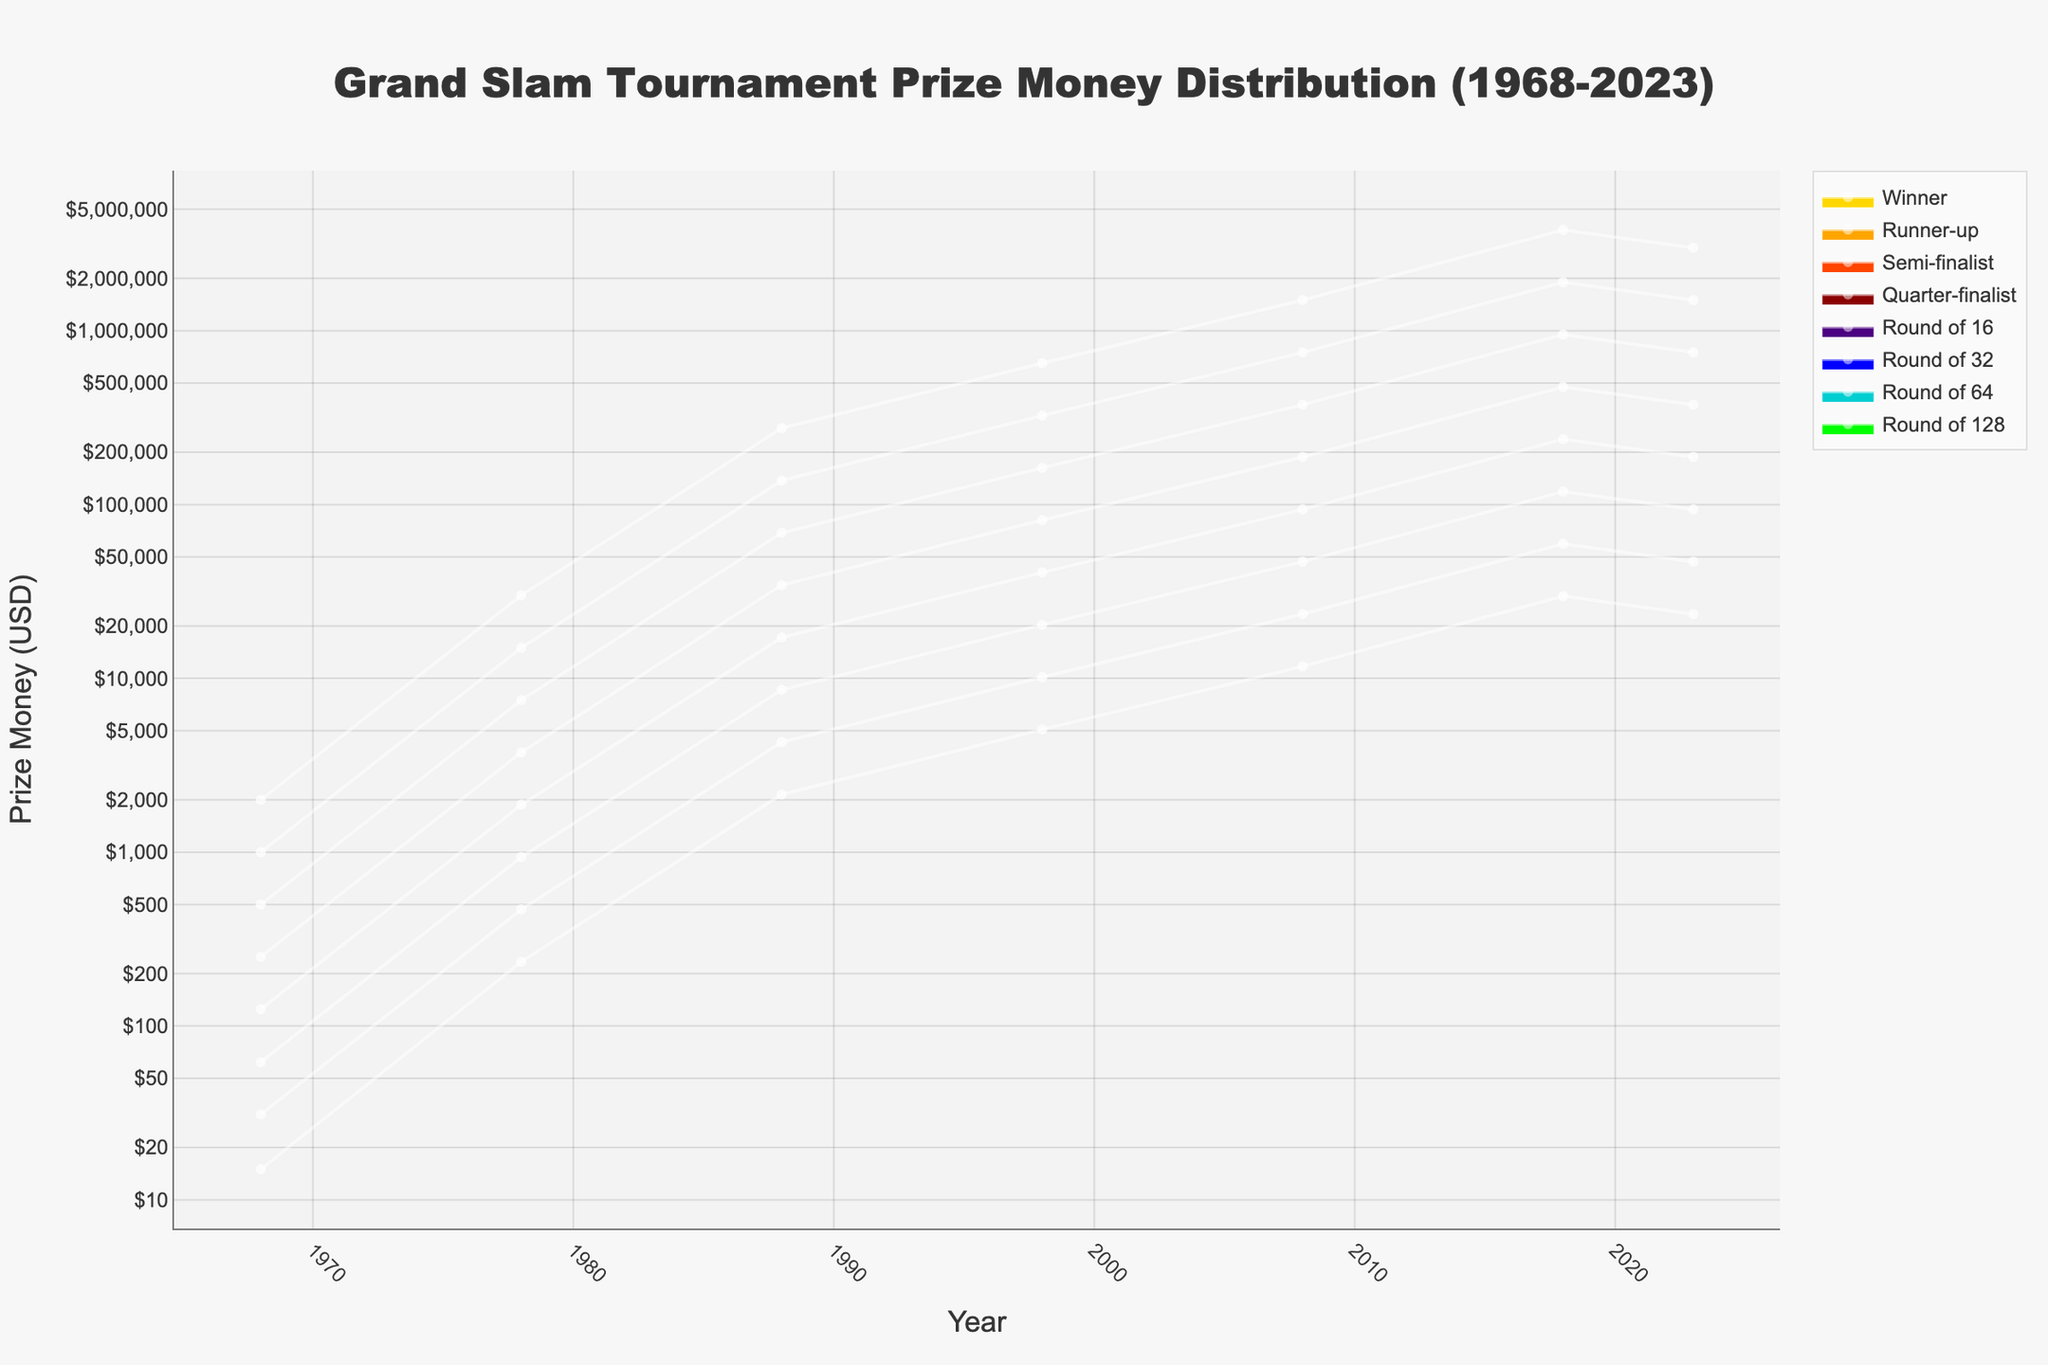What is the title of the figure? The title is usually at the top of the figure, summarized in a few words to denote the content of the chart.
Answer: Grand Slam Tournament Prize Money Distribution (1968-2023) How much prize money did the runner-up receive in 1988? The figure plots the prize money for each round over the years. Locate the year 1988 and then check the corresponding value for the runner-up.
Answer: $137,500 How did the prize money for the winners change from 2008 to 2023? To find this, look at the prize money for winners in 2008 and then in 2023. Calculate the difference between the two values.
Answer: Increased by $1,500,000 Which year shows the steepest increase in prize money for winners? Check the plot for significant jumps in the prize money for winners between consecutive years. The steepest, most noticeable increase will indicate the correct year.
Answer: 1978 Compare the prize money for semi-finalists and quarter-finalists in 2018. Which one is higher, and by how much? Locate the prize money values for semi-finalists and quarter-finalists in 2018. Subtract the quarter-finalist's amount from the semi-finalist's amount to find the difference.
Answer: Semi-finalists; $475,000 What is the general trend of the prize money from 1968 to 2023? Observe the overall direction of the prize money values across all rounds over the years. Identify if it's increasing, decreasing, or fluctuating.
Answer: Increasing In which round and year does the lowest prize money appear on the chart? Look for the smallest prize money value within the entire chart, noting the corresponding round and year.
Answer: Round of 128, 1968 Which round had a prize money of $1,406,250 in any given year? Identify from the figure where this specific value fits within the plotted data points across all rounds and years.
Answer: It does not exactly match any plotted value What is the prize money distribution pattern in 1978 compared to 1988? Contrast the prize money values for all rounds between the years 1978 and 1988, observing patterns or percentage increases.
Answer: Increased significantly across all rounds How does the prize money for winners evolve from 1968 to 2023? Focus on the winners' prize money over the entire duration of 1968 to 2023, noting any trends or significant changes.
Answer: Dramatically increases 